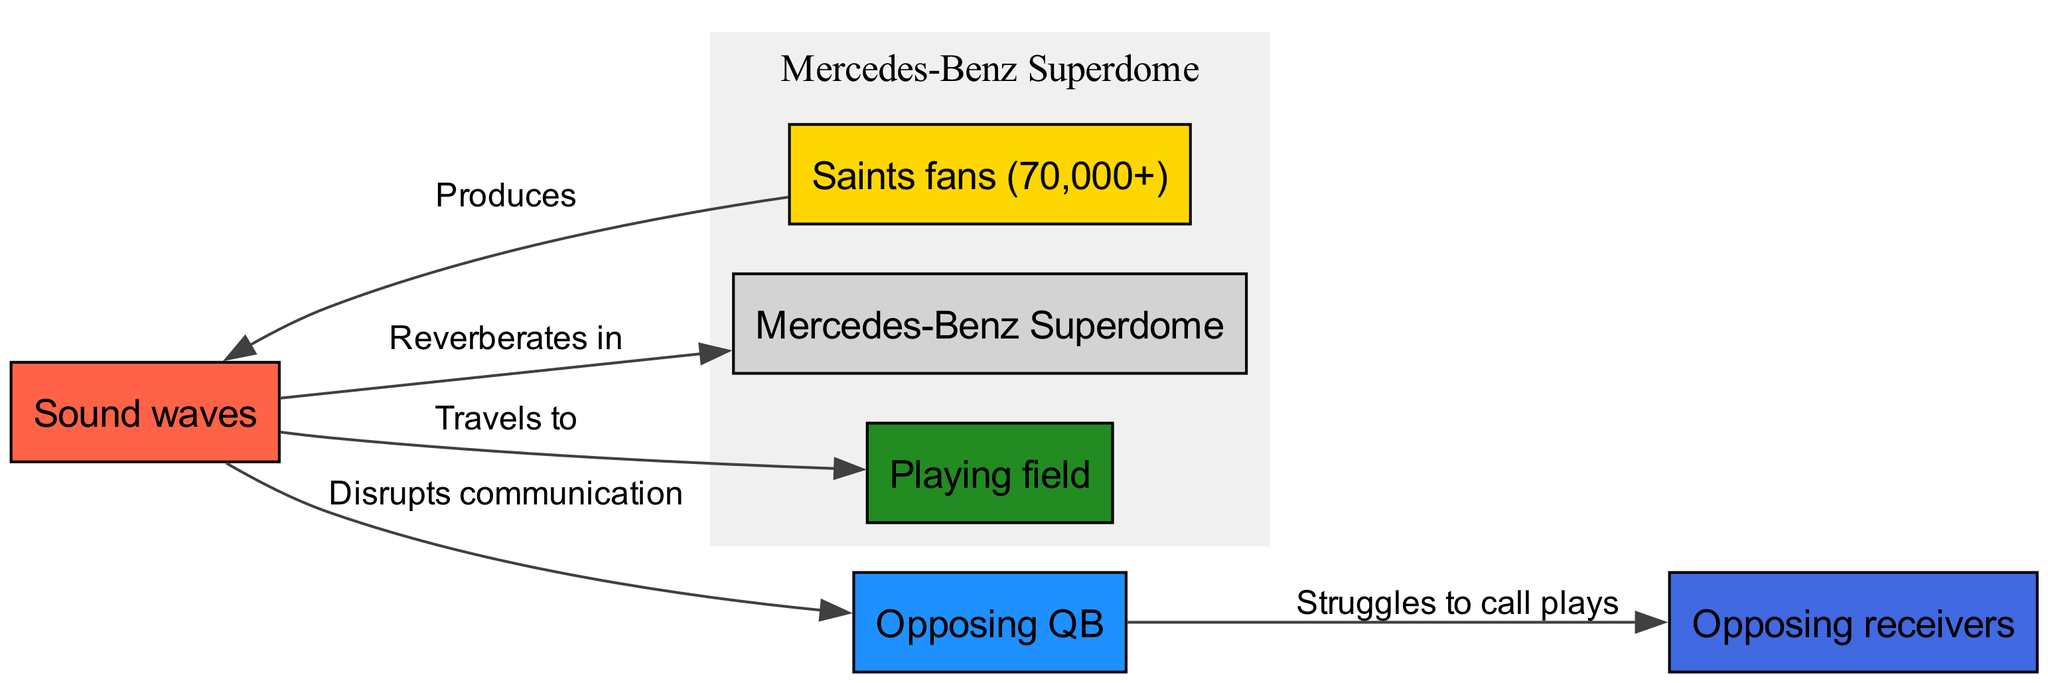What is the total number of nodes in the diagram? The diagram lists six distinct entities, which are the Mercedes-Benz Superdome, Saints fans, the playing field, the opposing quarterback, opposing receivers, and sound waves. Therefore, the total number of nodes is six.
Answer: 6 What effect do the sound waves have on the quarterback? According to the diagram, sound waves disrupt communication for the opposing quarterback. Thus, the direct effect indicated is a disruption to communication.
Answer: Disrupts communication How many edges are connecting the nodes? By counting the arrows connecting the nodes, there are five edges in total: the crowd produces sound waves, sound waves reverberate in the Superdome, travel to the field, disrupt communication with the quarterback, and the quarterback struggles to call plays with the receivers. Therefore, the total number of edges is five.
Answer: 5 What does the crowd produce? The diagram indicates that the crowd produces sound waves. There is a direct edge labeled "Produces" connecting the crowd to sound waves.
Answer: Sound waves What is the connection between the quarterback and the receivers? The edge labeled "Struggles to call plays" indicates that the opposing quarterback has difficulty communicating plays to the receivers because of the disruption caused by the sound waves. Thus, the relationship is one of struggle in communication between the two entities.
Answer: Struggles to call plays How do sound waves travel from the crowd to the field? The edges show that the crowd produces sound waves, which subsequently travel to the playing field. The direct relationship indicated by the edge labeled "Travels to" confirms the path from crowd to field via sound waves.
Answer: Travels to What is the main source of sound waves in the Superdome? The diagram designates the Saints fans as the source of sound waves, as indicated by the edge that states "Produces" leading to sound waves. Therefore, the main source is clearly identified as the crowd.
Answer: Saints fans Which node is affected by the reverberation of sound waves? The diagram shows that sound waves reverberate within the Superdome, pointing to the Superdome as the entity that is affected by sound wave reverberation specifically.
Answer: Superdome 